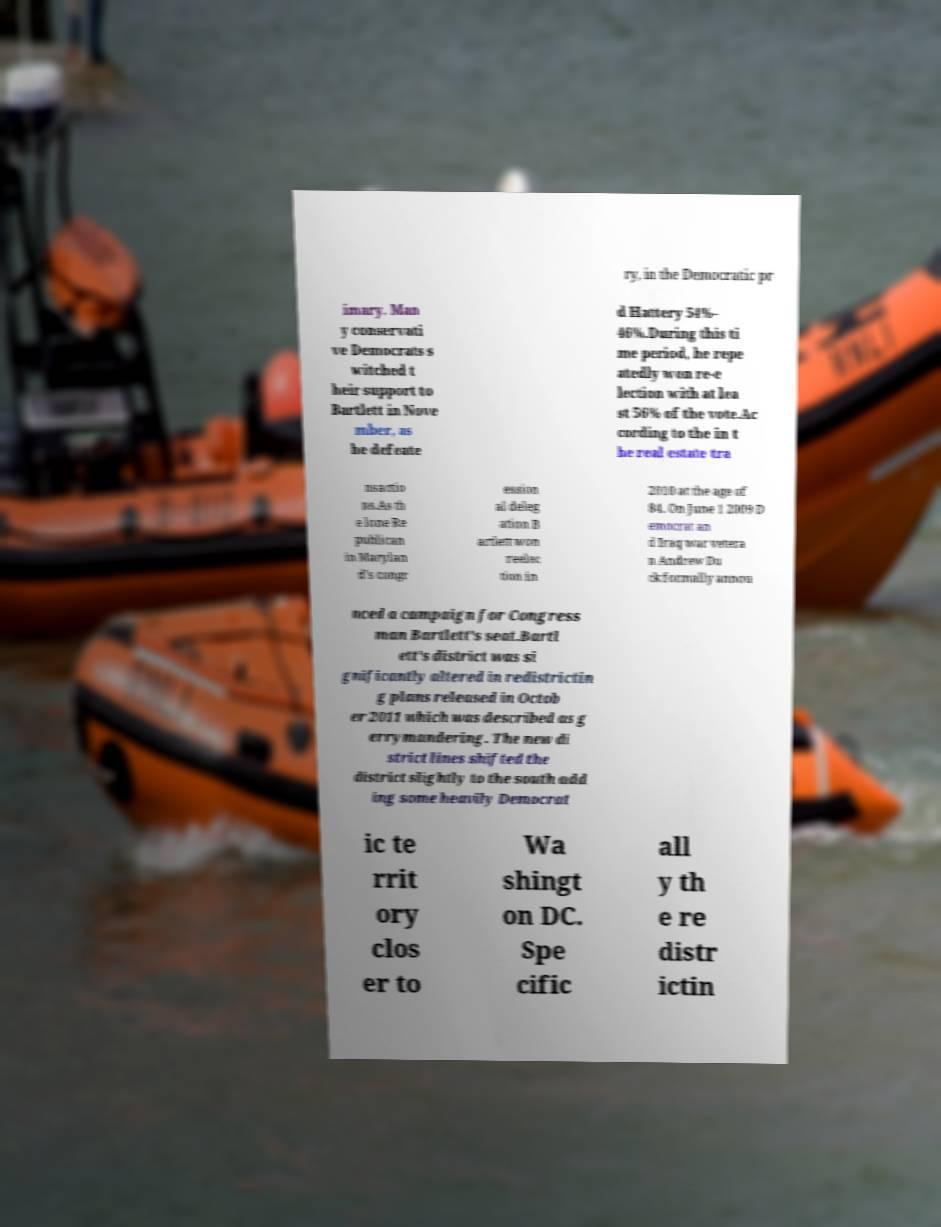What messages or text are displayed in this image? I need them in a readable, typed format. ry, in the Democratic pr imary. Man y conservati ve Democrats s witched t heir support to Bartlett in Nove mber, as he defeate d Hattery 54%– 46%.During this ti me period, he repe atedly won re-e lection with at lea st 56% of the vote.Ac cording to the in t he real estate tra nsactio ns.As th e lone Re publican in Marylan d's congr ession al deleg ation B artlett won reelec tion in 2010 at the age of 84. On June 1 2009 D emocrat an d Iraq war vetera n Andrew Du ck formally annou nced a campaign for Congress man Bartlett's seat.Bartl ett's district was si gnificantly altered in redistrictin g plans released in Octob er 2011 which was described as g errymandering. The new di strict lines shifted the district slightly to the south add ing some heavily Democrat ic te rrit ory clos er to Wa shingt on DC. Spe cific all y th e re distr ictin 